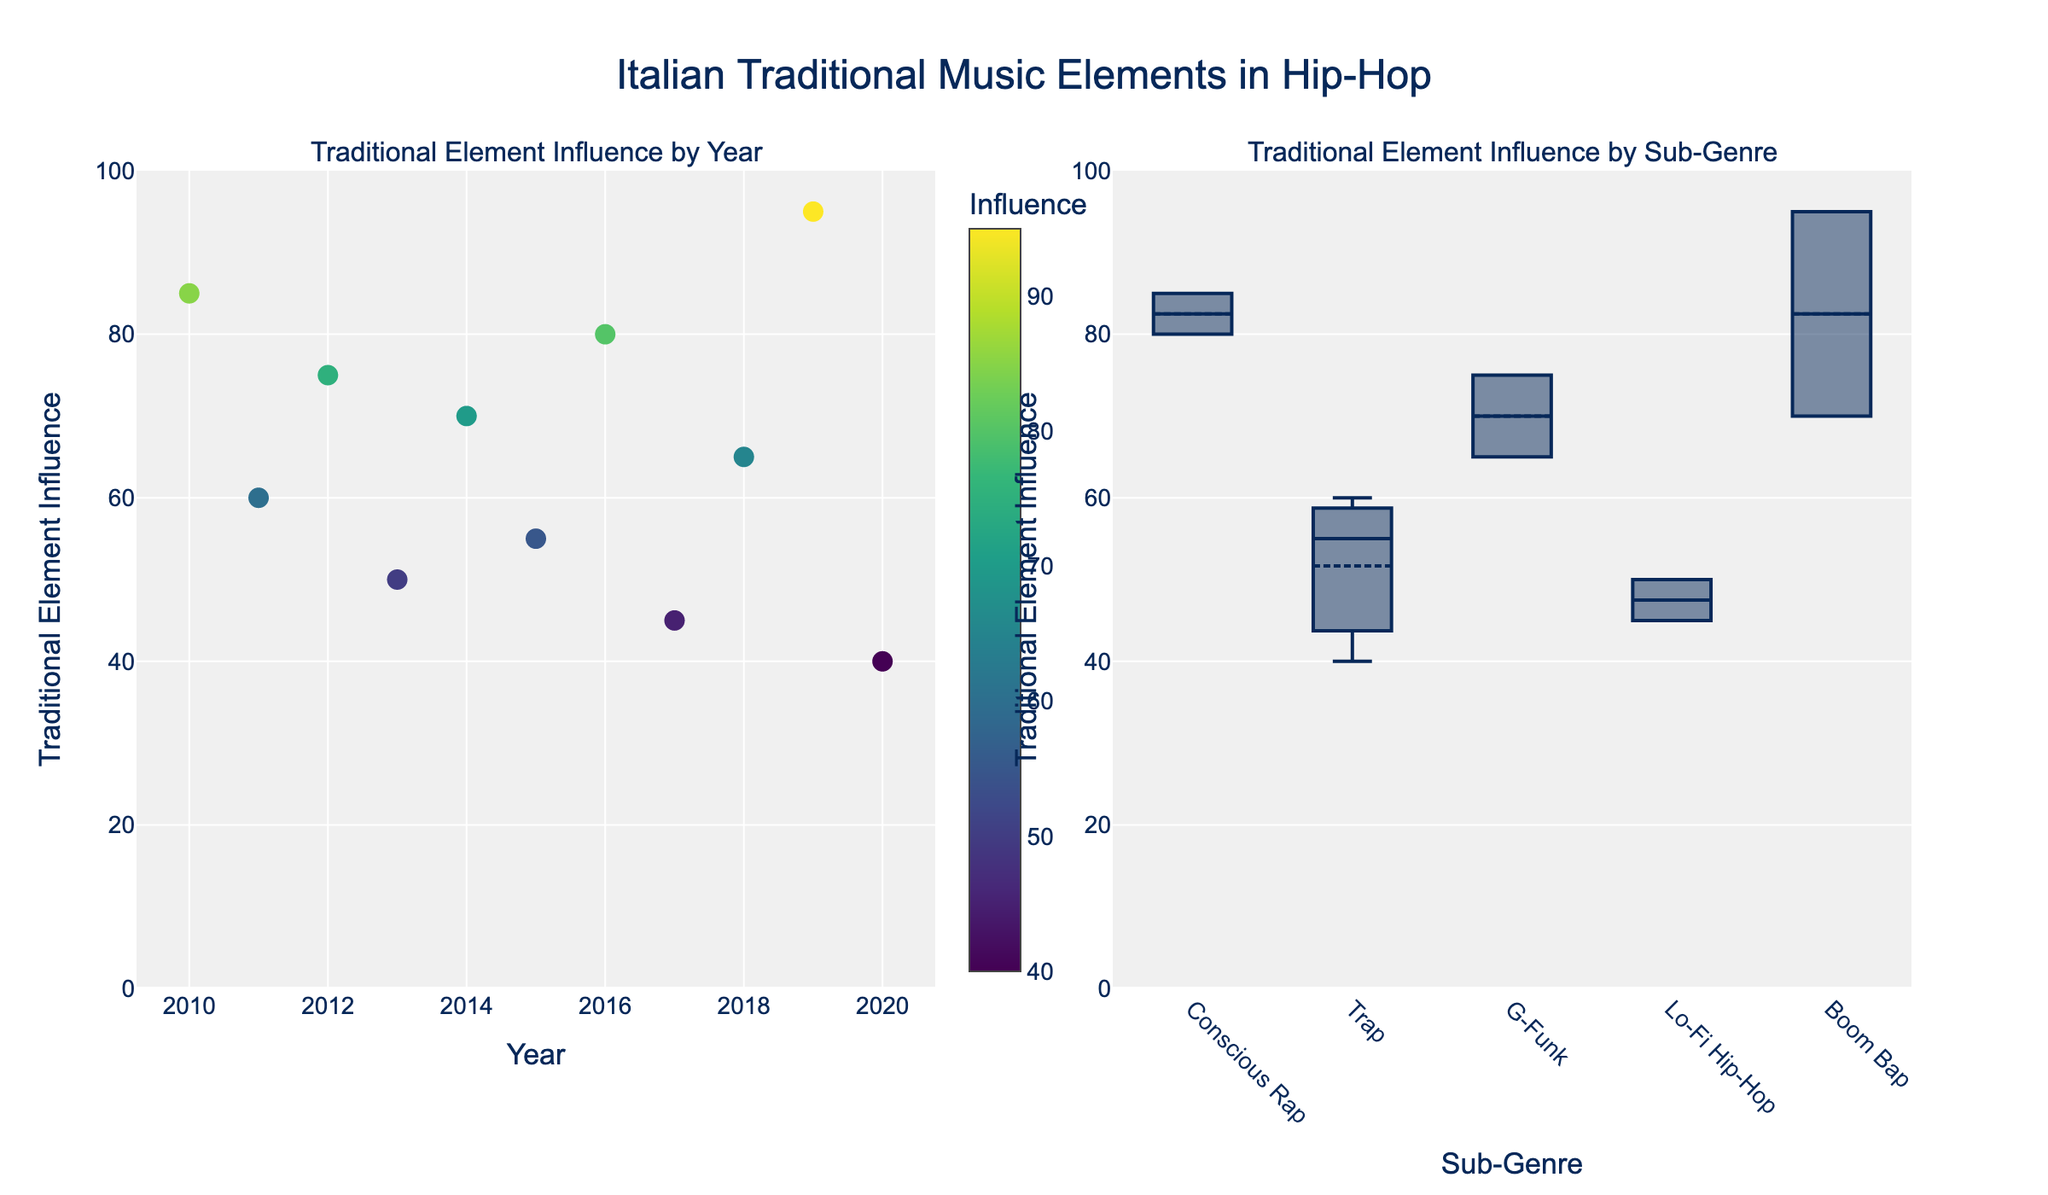what is the title of the figure? The title of the figure is located at the top center of the plot. It is typically a larger font size compared to other text in the plot. In this plot, it is "Italian Traditional Music Elements in Hip-Hop."
Answer: Italian Traditional Music Elements in Hip-Hop How many tracks are represented in the scatter plot? The scatter plot in the left subplot has one point for each track. To find out the number of tracks, count the number of points in the scatter plot.
Answer: 11 Which year has the highest traditional element influence? Look at the scatter plot on the left and identify the point with the highest value on the y-axis. This corresponds to the year 2019, where the influence is 95.
Answer: 2019 What type of sub-plot compares different sub-genres? The subplot comparing different sub-genres uses a box plot, which shows the distribution of traditional element influence across different sub-genres.
Answer: box plot Which sub-genre has the lowest median value of traditional element influence? In the box plot on the right subplot, the median value is indicated by the line inside each box. The sub-genre "Trap" has the box with the lowest line indicating its median.
Answer: Trap What is the average traditional element influence in Conscious Rap tracks? In the scatter plot, find the tracks in the "Conscious Rap" sub-genre and calculate their average influence values. The values are 85 (2010) and 80 (2016). Average = (85 + 80) / 2 = 82.5.
Answer: 82.5 Compare the traditional element influence between "Trap" and "Boom Bap"; which is higher on average? For "Trap," the average values are 60 (2011), 55 (2015), and 40 (2020), Average = (60 + 55 + 40) / 3 = 51.67. For "Boom Bap," the values are 70 (2014) and 95 (2019), Average = (70 + 95) / 2 = 82.5. Therefore, "Boom Bap" has a higher average.
Answer: Boom Bap How does the traditional element influence in 2019 compare to that in 2020? By looking at the scatter plot, the 2019 influence is 95 and the 2020 influence is 40. Therefore, the 2019 influence is higher.
Answer: 2019 is higher Which artist's track represents the highest traditional element influence in 2012? Use the scatter plot to locate the year 2012. The traditional element influence is 75, and the artist is "Colle der Fomento" with the track "Città Eterna."
Answer: Colle der Fomento What is the range of traditional element influence for Lo-Fi Hip-Hop? In the box plot for Lo-Fi Hip-Hop, the minimum and maximum values are represented by the whiskers of the box plot. The values for Lo-Fi Hip-Hop are 50 (2013) and 45 (2017), so the range is 50 - 45 = 5.
Answer: 5 